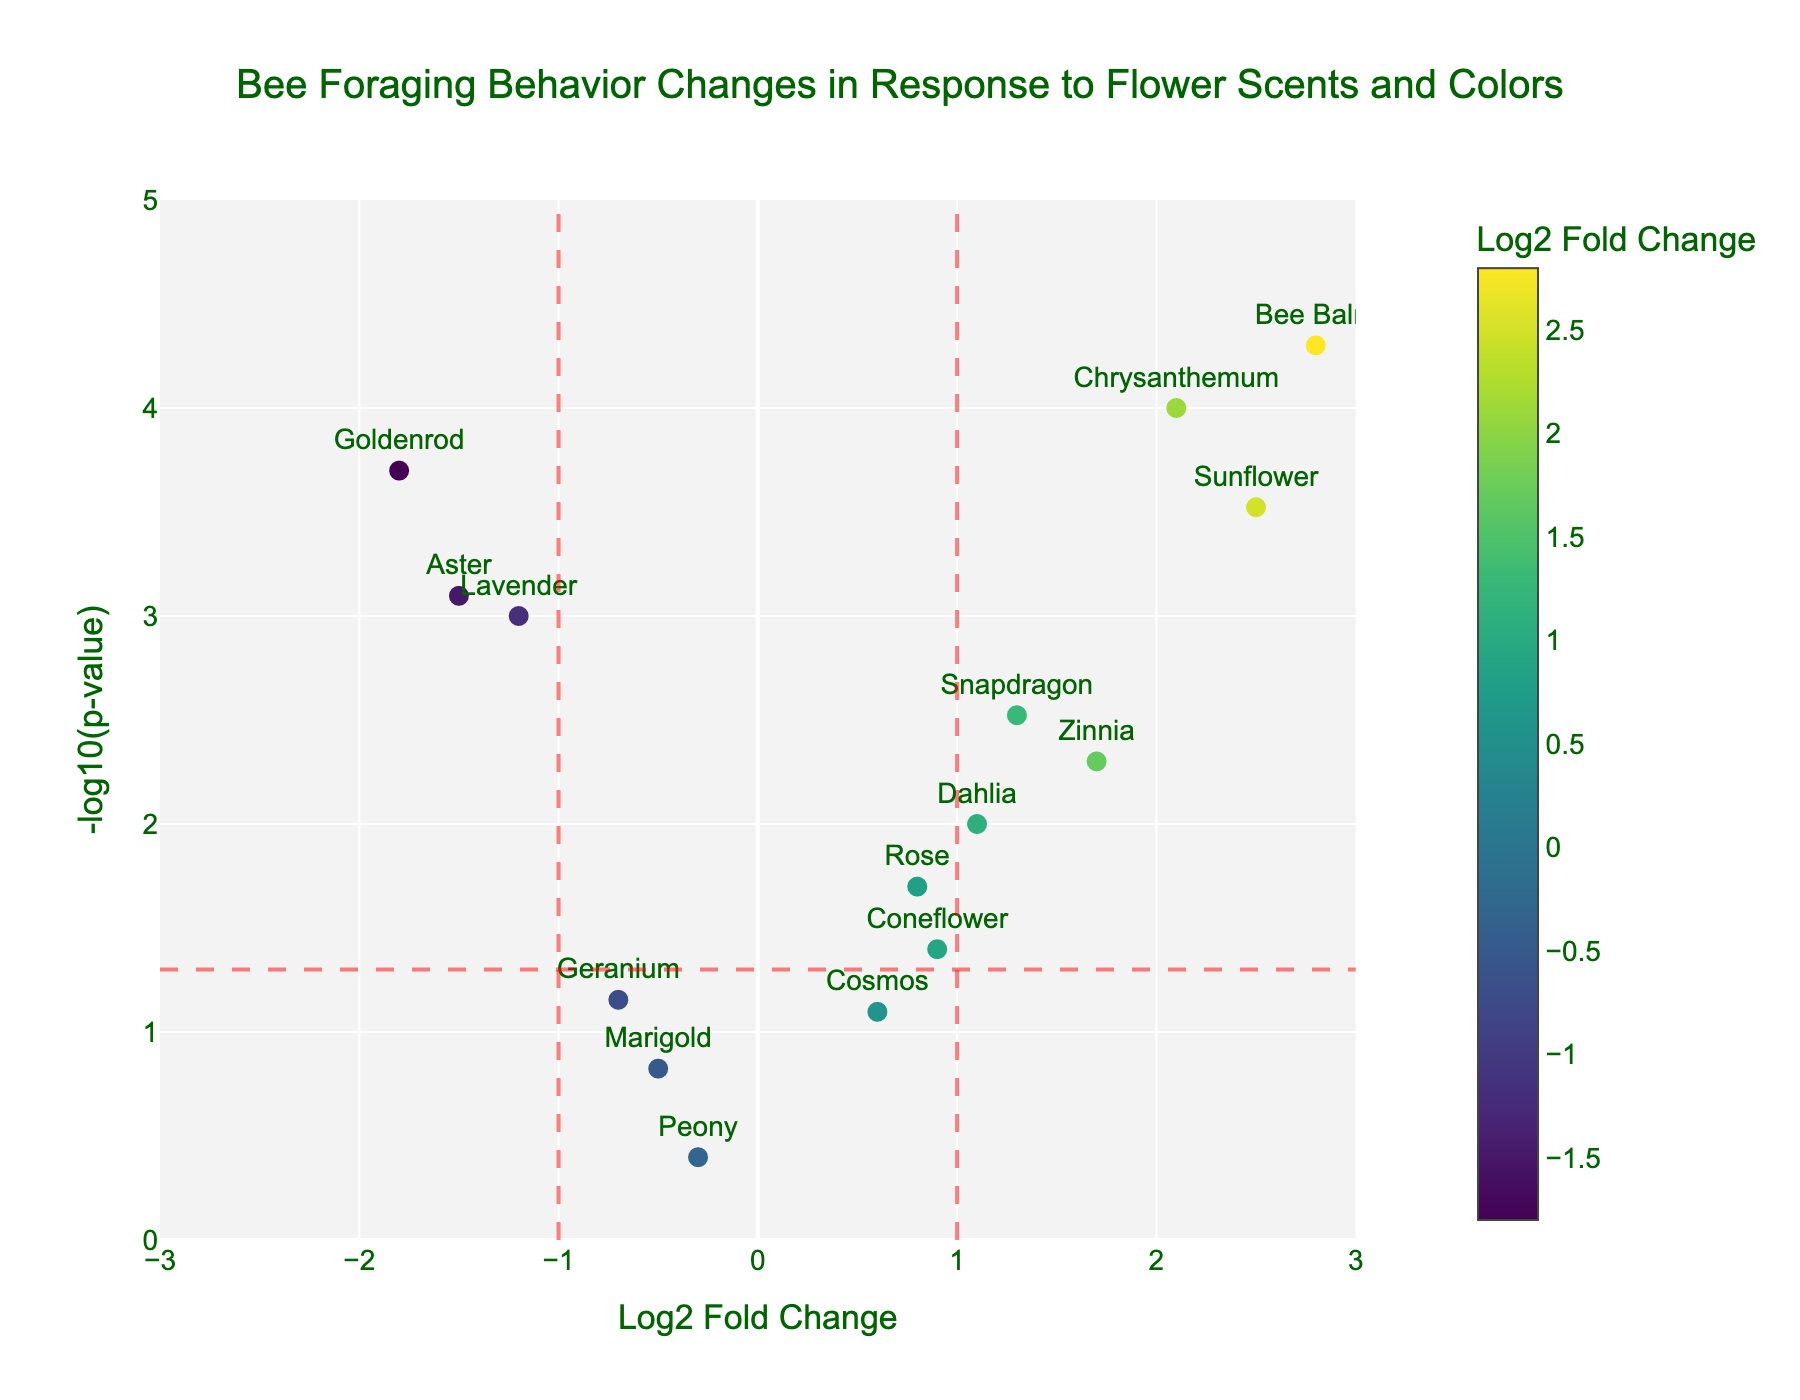What's the title of the plot? The title of the plot is displayed at the top center of the figure, which is "Bee Foraging Behavior Changes in Response to Flower Scents and Colors".
Answer: Bee Foraging Behavior Changes in Response to Flower Scents and Colors What's on the x-axis and y-axis of the plot? The labels of the x-axis and y-axis are displayed near the axes. The x-axis is "Log2 Fold Change", and the y-axis is "-log10(p-value)".
Answer: Log2 Fold Change and -log10(p-value) How many flowers have a Log2 Fold Change greater than 1? By looking at the plot, count all the markers that are positioned to the right of the vertical red dashed line at Log2 Fold Change = 1. The flowers are Sunflower, Zinnia, Chrysanthemum, Snapdragon, and Bee Balm.
Answer: 5 Which flower has the smallest p-value? The smallest p-value corresponds to the highest value of -log10(p-value). Identify the point with the highest y-value. This is Bee Balm.
Answer: Bee Balm Which flowers have significantly different bee foraging behavior? Flowers with significant differences are those situated above the horizontal red dashed line (-log10(0.05)) and outside the vertical red dashed lines (Log2 Fold Change of -1 and 1). These flowers are Lavender, Sunflower, Aster, Chrysanthemum, Bee Balm, and Goldenrod.
Answer: Lavender, Sunflower, Aster, Chrysanthemum, Bee Balm, Goldenrod What's the relationship between Log2 Fold Change and p-value for the flower Zinnia? Locate Zinnia on the plot and note its coordinate values. Zinnia is placed at a Log2 Fold Change of approximately 1.7 and a -log10(p-value) around 2.3, indicating it has a relatively high fold change with a significant p-value.
Answer: High fold change with significant p-value How does the foraging behavior change towards flowers with Log2 Fold Change nearly zero? Flowers near Log2 Fold Change of zero indicate little to no change in foraging behavior. Identify those points around zero on the x-axis. They include Rose, Marigold, Peony, Cosmos, Geranium, and Coneflower.
Answer: Little to no change What is the critical p-value for significant changes in foraging behavior? The critical p-value corresponds to the horizontal red dashed line at -log10(0.05). Thus, this critical value is 0.05, which means any p-value below 0.05 indicates significant changes.
Answer: 0.05 Which flower has the largest negative Log2 Fold Change? The largest negative Log2 Fold Change can be identified by the leftmost point on the plot. This point represents Goldenrod.
Answer: Goldenrod 